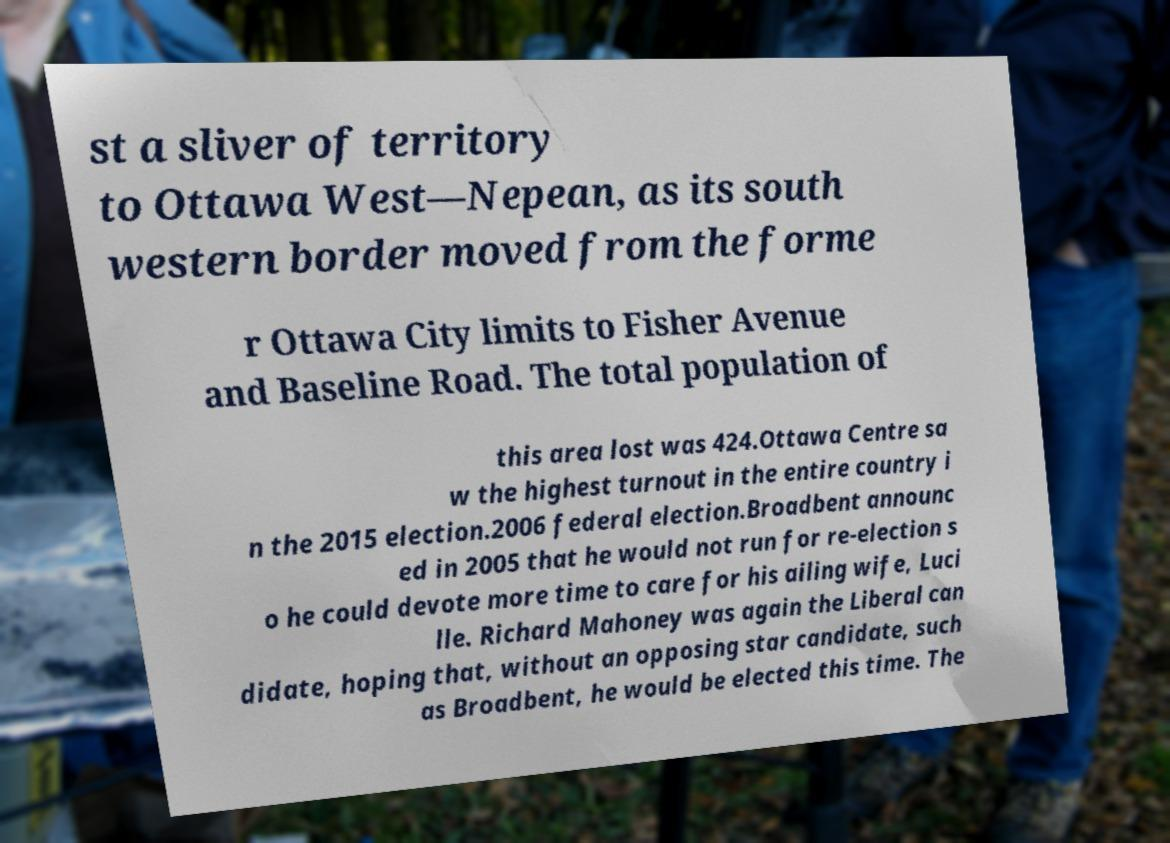I need the written content from this picture converted into text. Can you do that? st a sliver of territory to Ottawa West—Nepean, as its south western border moved from the forme r Ottawa City limits to Fisher Avenue and Baseline Road. The total population of this area lost was 424.Ottawa Centre sa w the highest turnout in the entire country i n the 2015 election.2006 federal election.Broadbent announc ed in 2005 that he would not run for re-election s o he could devote more time to care for his ailing wife, Luci lle. Richard Mahoney was again the Liberal can didate, hoping that, without an opposing star candidate, such as Broadbent, he would be elected this time. The 